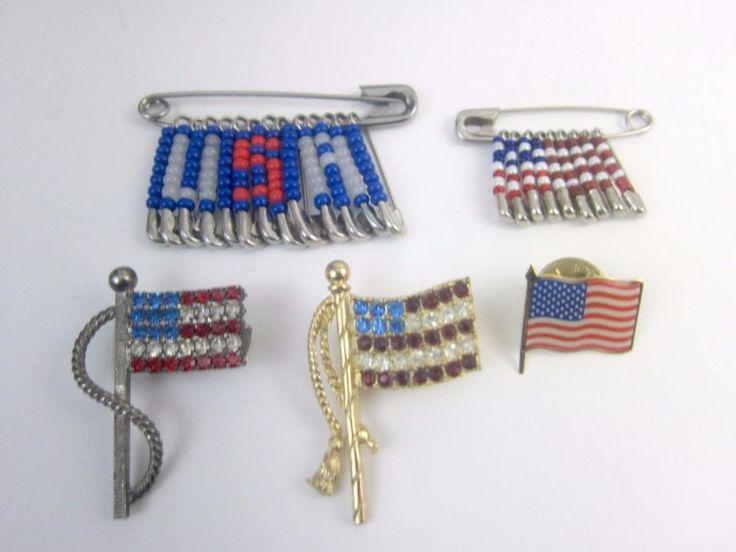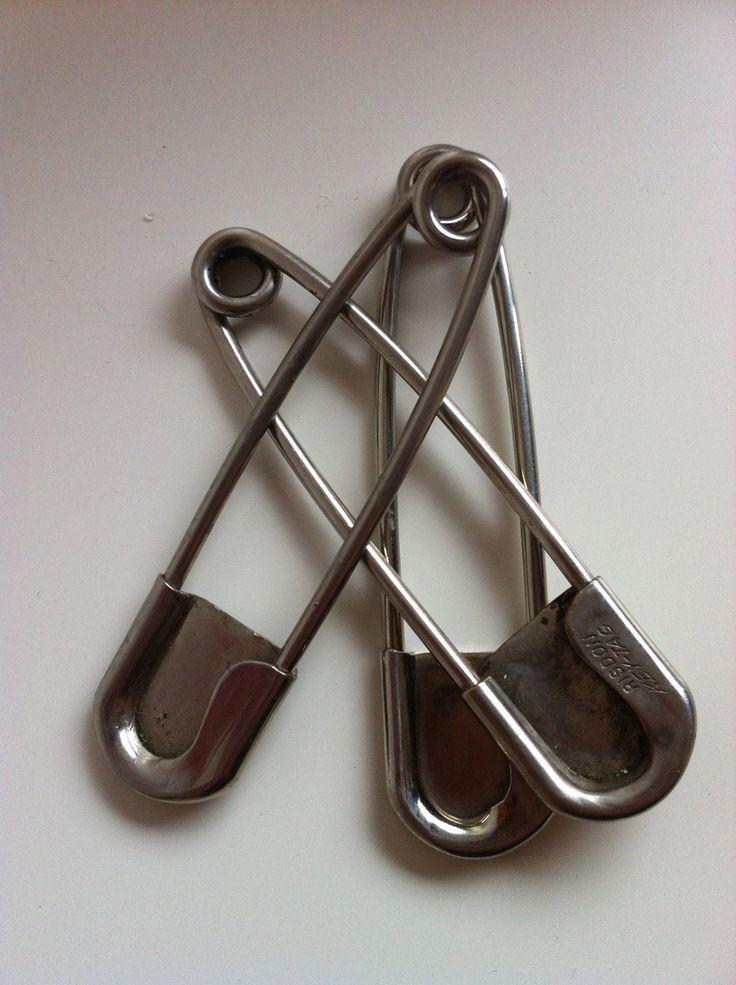The first image is the image on the left, the second image is the image on the right. Examine the images to the left and right. Is the description "There is one pin in the right image." accurate? Answer yes or no. No. The first image is the image on the left, the second image is the image on the right. Assess this claim about the two images: "There are no less than three plain safety pins without any beads". Correct or not? Answer yes or no. Yes. 